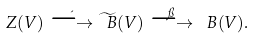<formula> <loc_0><loc_0><loc_500><loc_500>Z ( V ) \stackrel { \iota } { \longrightarrow } \widetilde { \ B } ( V ) \stackrel { \pi } { \longrightarrow } \ B ( V ) .</formula> 